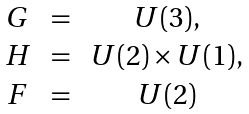Convert formula to latex. <formula><loc_0><loc_0><loc_500><loc_500>\begin{array} { c c c } G & \, = \, & U ( 3 ) , \\ H & \, = \, & U ( 2 ) \times U ( 1 ) , \\ F & \, = \, & U ( 2 ) \end{array}</formula> 